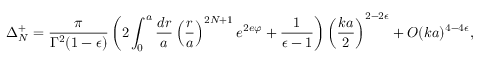Convert formula to latex. <formula><loc_0><loc_0><loc_500><loc_500>\Delta _ { N } ^ { + } = \frac { \pi } { \Gamma ^ { 2 } ( 1 - \epsilon ) } \left ( 2 \int _ { 0 } ^ { a } \frac { d r } { a } \left ( \frac { r } { a } \right ) ^ { 2 N + 1 } e ^ { 2 e \varphi } + \frac { 1 } { \epsilon - 1 } \right ) \left ( \frac { k a } { 2 } \right ) ^ { 2 - 2 \epsilon } + O ( k a ) ^ { 4 - 4 \epsilon } ,</formula> 